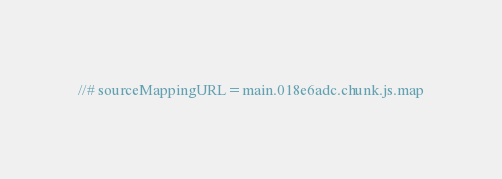<code> <loc_0><loc_0><loc_500><loc_500><_JavaScript_>//# sourceMappingURL=main.018e6adc.chunk.js.map</code> 